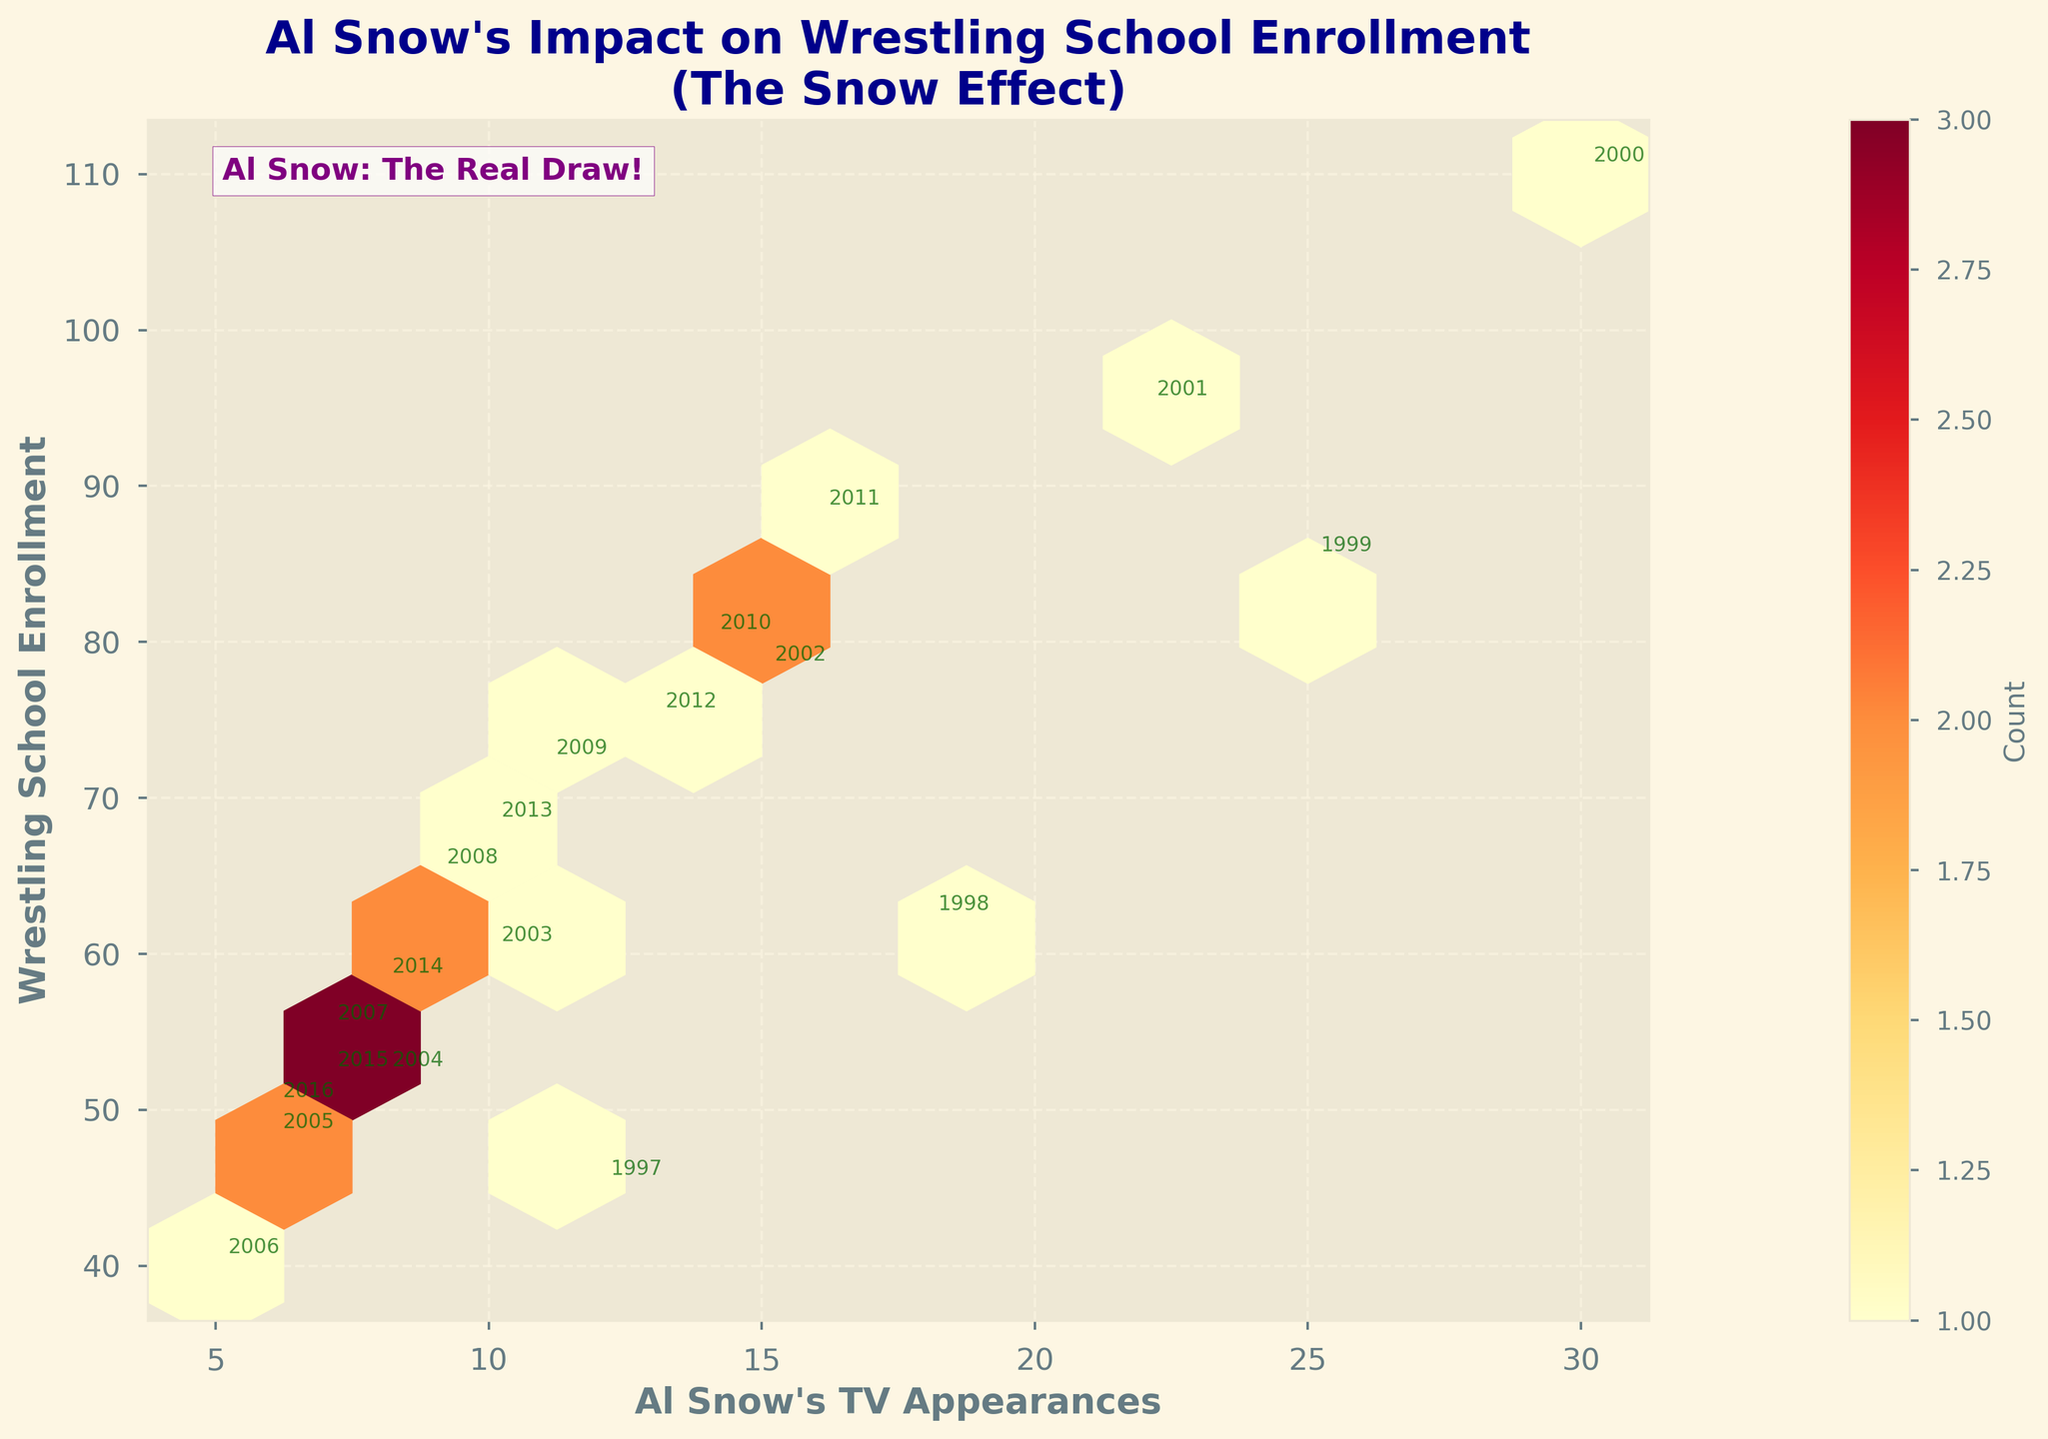What is the title of the plot? The title of the plot is written at the top and says "Al Snow's Impact on Wrestling School Enrollment\n(The Snow Effect)".
Answer: Al Snow's Impact on Wrestling School Enrollment (The Snow Effect) How many data points are shown in the plot? Each point on the hexbin plot corresponds to a data point. By counting the annotations (years), there are 20 data points shown.
Answer: 20 What trend does the color intensity in the hexagons indicate? Darker hexagons indicate a higher count of data points in that bin, while lighter hexagons represent fewer data points. This suggests areas of denser data.
Answer: Higher count What is the relationship between Al Snow's TV appearances and wrestling school enrollment numbers? Some hexagons are more densely colored, suggesting a positive correlation between TV appearances and enrollments, especially noticeable when TV appearances are between 10 and 30.
Answer: Positive correlation Which year had the highest number of TV appearances and what was the enrollment for that year? The year 2000 had the highest number of TV appearances (30) and the enrollment for that year was 110. This is annotated on the plot.
Answer: 2000, 110 In which year did the enrollment peak, and what were the number of TV appearances that year? By observing the annotations and hexbin plot, the enrollment peaked in the year 2000 with 110 enrollments and 30 TV appearances.
Answer: 2000, 30 How many years had TV appearances less than or equal to 10? By identifying the annotated years where TV appearances are less than or equal to 10, we see years 2003, 2004, 2005, 2006, 2014, 2015, and 2016. This equals 7 years.
Answer: 7 What is the value of the lowest enrollment, and in which year did it occur? By reading the annotations, the lowest enrollment number is 40, which occurred in the year 2006.
Answer: 40, 2006 How does the enrollment trend change from 1997 to 2006 when TV appearances decrease? The annotations and hexbin plot show a general decrease in enrollment numbers as TV appearances decrease from 1997 (12 TV appearances, 45 enrollments) to 2006 (5 TV appearances, 40 enrollments).
Answer: Decreases What visual cue indicates that the data points for years with high TV appearances are tightly clustered? The hexagons with the higher count (darker shades) are concentrated around values where TV appearances are higher, indicating tight clustering of data points in those regions.
Answer: Darker hexagons 